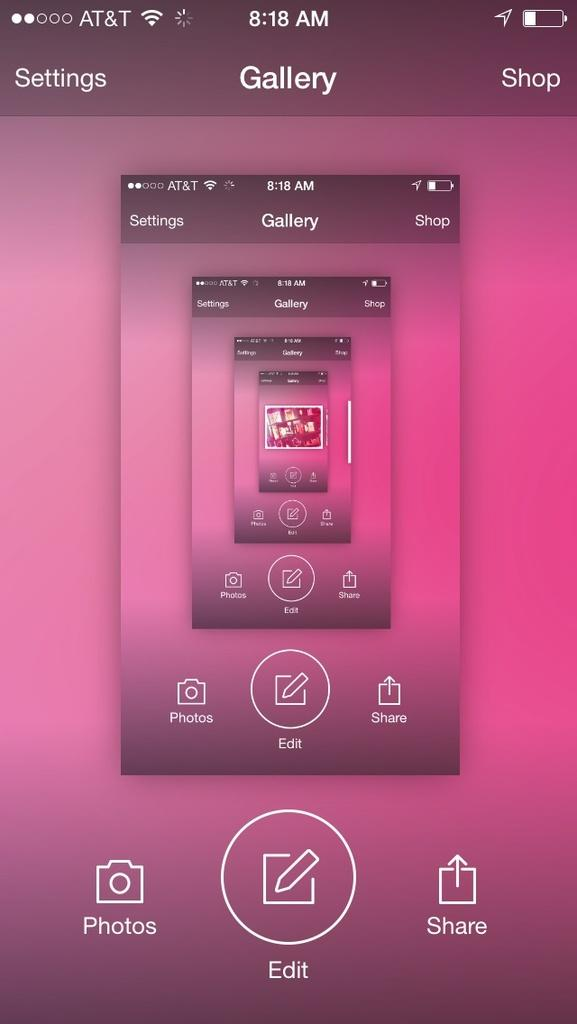Provide a one-sentence caption for the provided image. an AT&T cell phone in Gallery app editing a photo. 